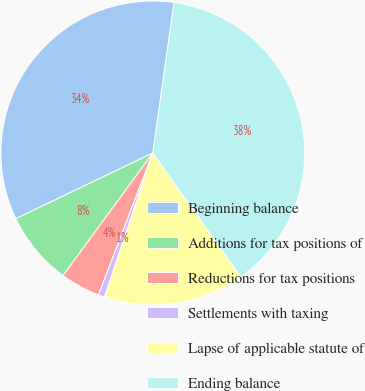<chart> <loc_0><loc_0><loc_500><loc_500><pie_chart><fcel>Beginning balance<fcel>Additions for tax positions of<fcel>Reductions for tax positions<fcel>Settlements with taxing<fcel>Lapse of applicable statute of<fcel>Ending balance<nl><fcel>34.36%<fcel>7.82%<fcel>4.24%<fcel>0.66%<fcel>14.98%<fcel>37.94%<nl></chart> 